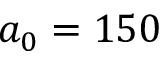Convert formula to latex. <formula><loc_0><loc_0><loc_500><loc_500>a _ { 0 } = 1 5 0</formula> 